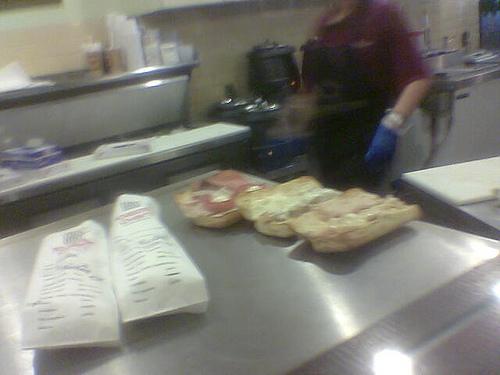What color is her shirt?
Quick response, please. Purple. What color are her gloves?
Quick response, please. Blue. What type of shelf is the sandwich sitting on?
Answer briefly. Metal. Is this a restaurant kitchen?
Be succinct. Yes. How many white cups?
Concise answer only. 0. 